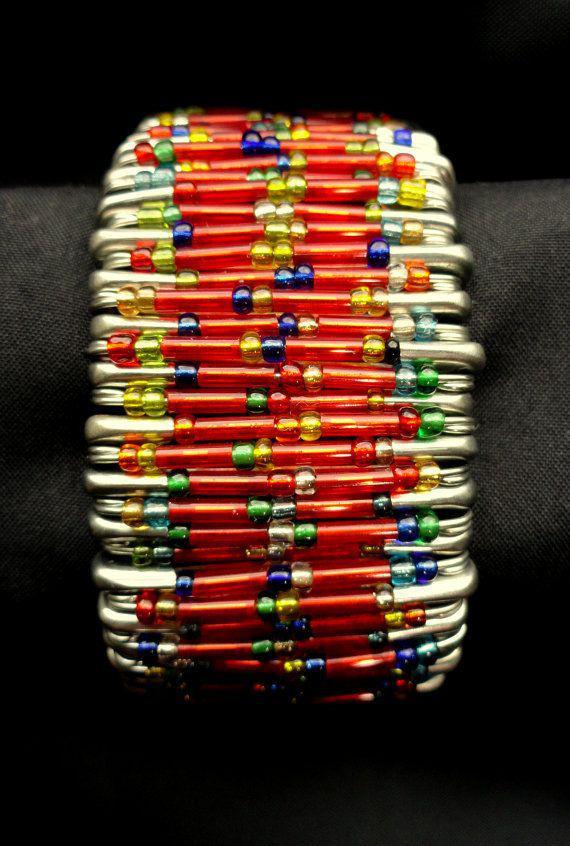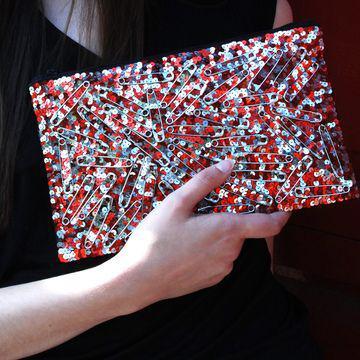The first image is the image on the left, the second image is the image on the right. Analyze the images presented: Is the assertion "One image shows one bracelet made of beaded safety pins." valid? Answer yes or no. Yes. The first image is the image on the left, the second image is the image on the right. Given the left and right images, does the statement "There is a bracelet in the image on the left." hold true? Answer yes or no. Yes. 